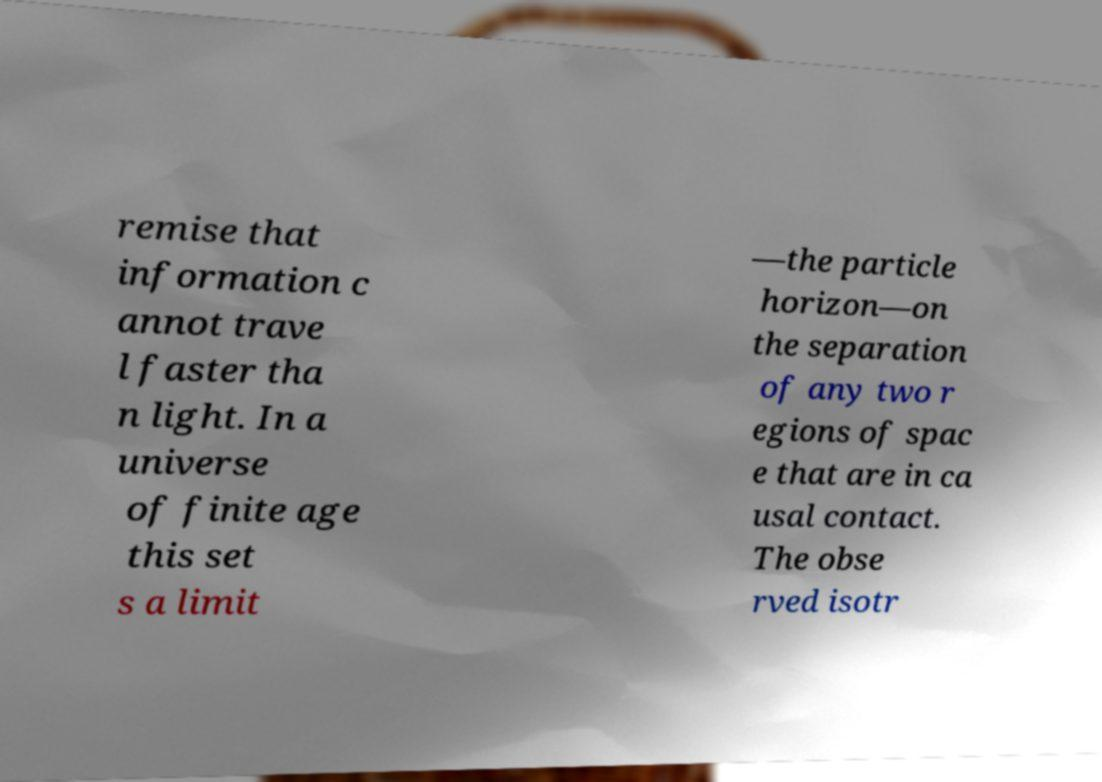For documentation purposes, I need the text within this image transcribed. Could you provide that? remise that information c annot trave l faster tha n light. In a universe of finite age this set s a limit —the particle horizon—on the separation of any two r egions of spac e that are in ca usal contact. The obse rved isotr 